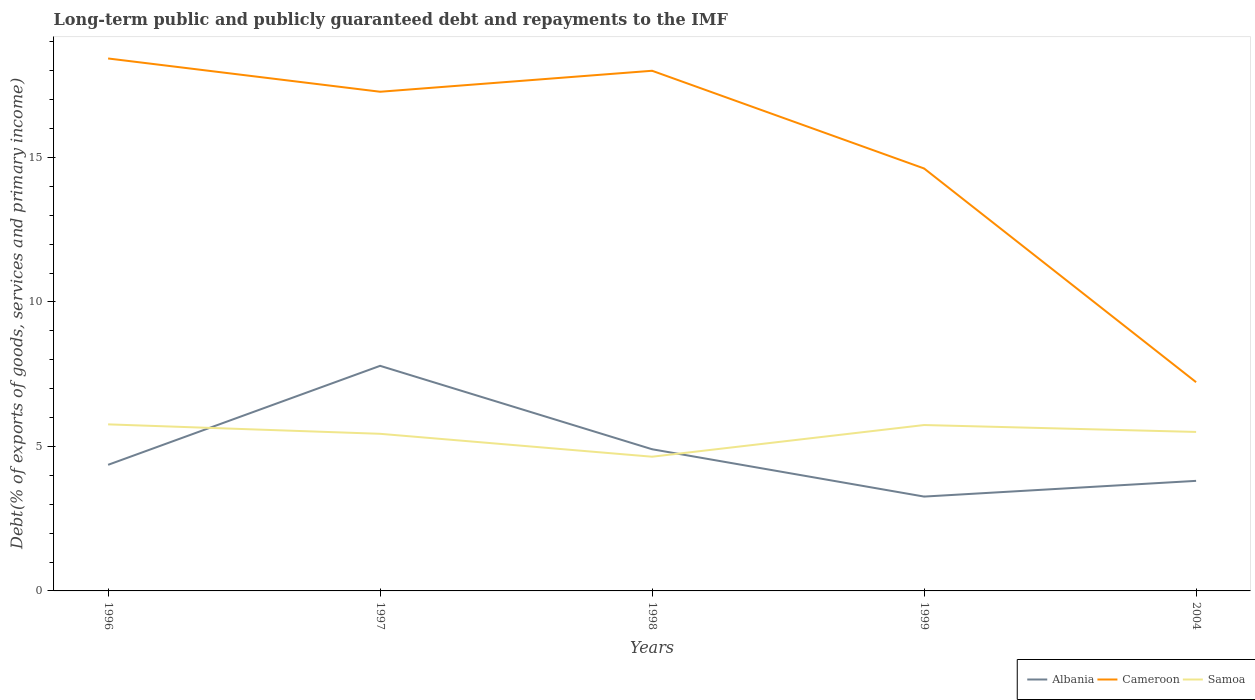How many different coloured lines are there?
Make the answer very short. 3. Does the line corresponding to Cameroon intersect with the line corresponding to Albania?
Your answer should be very brief. No. Across all years, what is the maximum debt and repayments in Cameroon?
Your answer should be very brief. 7.22. What is the total debt and repayments in Samoa in the graph?
Your answer should be compact. 0.26. What is the difference between the highest and the second highest debt and repayments in Cameroon?
Provide a succinct answer. 11.2. What is the difference between the highest and the lowest debt and repayments in Cameroon?
Give a very brief answer. 3. Is the debt and repayments in Albania strictly greater than the debt and repayments in Cameroon over the years?
Your answer should be compact. Yes. How many years are there in the graph?
Ensure brevity in your answer.  5. What is the difference between two consecutive major ticks on the Y-axis?
Give a very brief answer. 5. Are the values on the major ticks of Y-axis written in scientific E-notation?
Offer a terse response. No. Where does the legend appear in the graph?
Your answer should be compact. Bottom right. What is the title of the graph?
Provide a short and direct response. Long-term public and publicly guaranteed debt and repayments to the IMF. What is the label or title of the Y-axis?
Keep it short and to the point. Debt(% of exports of goods, services and primary income). What is the Debt(% of exports of goods, services and primary income) in Albania in 1996?
Keep it short and to the point. 4.36. What is the Debt(% of exports of goods, services and primary income) of Cameroon in 1996?
Offer a terse response. 18.43. What is the Debt(% of exports of goods, services and primary income) in Samoa in 1996?
Offer a very short reply. 5.76. What is the Debt(% of exports of goods, services and primary income) in Albania in 1997?
Make the answer very short. 7.79. What is the Debt(% of exports of goods, services and primary income) of Cameroon in 1997?
Offer a terse response. 17.27. What is the Debt(% of exports of goods, services and primary income) of Samoa in 1997?
Ensure brevity in your answer.  5.44. What is the Debt(% of exports of goods, services and primary income) of Albania in 1998?
Offer a terse response. 4.9. What is the Debt(% of exports of goods, services and primary income) in Cameroon in 1998?
Give a very brief answer. 18. What is the Debt(% of exports of goods, services and primary income) of Samoa in 1998?
Your answer should be very brief. 4.64. What is the Debt(% of exports of goods, services and primary income) of Albania in 1999?
Your answer should be very brief. 3.26. What is the Debt(% of exports of goods, services and primary income) of Cameroon in 1999?
Offer a very short reply. 14.62. What is the Debt(% of exports of goods, services and primary income) of Samoa in 1999?
Keep it short and to the point. 5.74. What is the Debt(% of exports of goods, services and primary income) in Albania in 2004?
Give a very brief answer. 3.81. What is the Debt(% of exports of goods, services and primary income) of Cameroon in 2004?
Your answer should be very brief. 7.22. What is the Debt(% of exports of goods, services and primary income) of Samoa in 2004?
Make the answer very short. 5.5. Across all years, what is the maximum Debt(% of exports of goods, services and primary income) of Albania?
Provide a succinct answer. 7.79. Across all years, what is the maximum Debt(% of exports of goods, services and primary income) in Cameroon?
Give a very brief answer. 18.43. Across all years, what is the maximum Debt(% of exports of goods, services and primary income) of Samoa?
Your answer should be very brief. 5.76. Across all years, what is the minimum Debt(% of exports of goods, services and primary income) of Albania?
Offer a very short reply. 3.26. Across all years, what is the minimum Debt(% of exports of goods, services and primary income) of Cameroon?
Ensure brevity in your answer.  7.22. Across all years, what is the minimum Debt(% of exports of goods, services and primary income) in Samoa?
Keep it short and to the point. 4.64. What is the total Debt(% of exports of goods, services and primary income) in Albania in the graph?
Your answer should be compact. 24.13. What is the total Debt(% of exports of goods, services and primary income) in Cameroon in the graph?
Offer a terse response. 75.54. What is the total Debt(% of exports of goods, services and primary income) of Samoa in the graph?
Offer a terse response. 27.09. What is the difference between the Debt(% of exports of goods, services and primary income) in Albania in 1996 and that in 1997?
Your answer should be very brief. -3.43. What is the difference between the Debt(% of exports of goods, services and primary income) of Cameroon in 1996 and that in 1997?
Ensure brevity in your answer.  1.15. What is the difference between the Debt(% of exports of goods, services and primary income) of Samoa in 1996 and that in 1997?
Provide a short and direct response. 0.33. What is the difference between the Debt(% of exports of goods, services and primary income) in Albania in 1996 and that in 1998?
Make the answer very short. -0.54. What is the difference between the Debt(% of exports of goods, services and primary income) in Cameroon in 1996 and that in 1998?
Ensure brevity in your answer.  0.43. What is the difference between the Debt(% of exports of goods, services and primary income) in Samoa in 1996 and that in 1998?
Your answer should be compact. 1.12. What is the difference between the Debt(% of exports of goods, services and primary income) in Albania in 1996 and that in 1999?
Provide a succinct answer. 1.1. What is the difference between the Debt(% of exports of goods, services and primary income) of Cameroon in 1996 and that in 1999?
Offer a terse response. 3.81. What is the difference between the Debt(% of exports of goods, services and primary income) in Samoa in 1996 and that in 1999?
Your answer should be very brief. 0.02. What is the difference between the Debt(% of exports of goods, services and primary income) in Albania in 1996 and that in 2004?
Offer a very short reply. 0.56. What is the difference between the Debt(% of exports of goods, services and primary income) of Cameroon in 1996 and that in 2004?
Your answer should be very brief. 11.2. What is the difference between the Debt(% of exports of goods, services and primary income) in Samoa in 1996 and that in 2004?
Make the answer very short. 0.26. What is the difference between the Debt(% of exports of goods, services and primary income) of Albania in 1997 and that in 1998?
Provide a short and direct response. 2.89. What is the difference between the Debt(% of exports of goods, services and primary income) in Cameroon in 1997 and that in 1998?
Your answer should be very brief. -0.73. What is the difference between the Debt(% of exports of goods, services and primary income) of Samoa in 1997 and that in 1998?
Offer a very short reply. 0.79. What is the difference between the Debt(% of exports of goods, services and primary income) in Albania in 1997 and that in 1999?
Offer a terse response. 4.52. What is the difference between the Debt(% of exports of goods, services and primary income) in Cameroon in 1997 and that in 1999?
Give a very brief answer. 2.65. What is the difference between the Debt(% of exports of goods, services and primary income) of Samoa in 1997 and that in 1999?
Provide a short and direct response. -0.3. What is the difference between the Debt(% of exports of goods, services and primary income) of Albania in 1997 and that in 2004?
Ensure brevity in your answer.  3.98. What is the difference between the Debt(% of exports of goods, services and primary income) in Cameroon in 1997 and that in 2004?
Keep it short and to the point. 10.05. What is the difference between the Debt(% of exports of goods, services and primary income) of Samoa in 1997 and that in 2004?
Make the answer very short. -0.06. What is the difference between the Debt(% of exports of goods, services and primary income) of Albania in 1998 and that in 1999?
Your answer should be compact. 1.64. What is the difference between the Debt(% of exports of goods, services and primary income) in Cameroon in 1998 and that in 1999?
Your answer should be compact. 3.38. What is the difference between the Debt(% of exports of goods, services and primary income) of Samoa in 1998 and that in 1999?
Keep it short and to the point. -1.1. What is the difference between the Debt(% of exports of goods, services and primary income) of Albania in 1998 and that in 2004?
Offer a very short reply. 1.09. What is the difference between the Debt(% of exports of goods, services and primary income) of Cameroon in 1998 and that in 2004?
Provide a short and direct response. 10.78. What is the difference between the Debt(% of exports of goods, services and primary income) in Samoa in 1998 and that in 2004?
Make the answer very short. -0.86. What is the difference between the Debt(% of exports of goods, services and primary income) in Albania in 1999 and that in 2004?
Keep it short and to the point. -0.54. What is the difference between the Debt(% of exports of goods, services and primary income) of Cameroon in 1999 and that in 2004?
Offer a very short reply. 7.4. What is the difference between the Debt(% of exports of goods, services and primary income) of Samoa in 1999 and that in 2004?
Offer a terse response. 0.24. What is the difference between the Debt(% of exports of goods, services and primary income) in Albania in 1996 and the Debt(% of exports of goods, services and primary income) in Cameroon in 1997?
Your response must be concise. -12.91. What is the difference between the Debt(% of exports of goods, services and primary income) of Albania in 1996 and the Debt(% of exports of goods, services and primary income) of Samoa in 1997?
Your response must be concise. -1.07. What is the difference between the Debt(% of exports of goods, services and primary income) in Cameroon in 1996 and the Debt(% of exports of goods, services and primary income) in Samoa in 1997?
Make the answer very short. 12.99. What is the difference between the Debt(% of exports of goods, services and primary income) in Albania in 1996 and the Debt(% of exports of goods, services and primary income) in Cameroon in 1998?
Provide a succinct answer. -13.64. What is the difference between the Debt(% of exports of goods, services and primary income) in Albania in 1996 and the Debt(% of exports of goods, services and primary income) in Samoa in 1998?
Give a very brief answer. -0.28. What is the difference between the Debt(% of exports of goods, services and primary income) in Cameroon in 1996 and the Debt(% of exports of goods, services and primary income) in Samoa in 1998?
Your answer should be very brief. 13.78. What is the difference between the Debt(% of exports of goods, services and primary income) in Albania in 1996 and the Debt(% of exports of goods, services and primary income) in Cameroon in 1999?
Give a very brief answer. -10.26. What is the difference between the Debt(% of exports of goods, services and primary income) of Albania in 1996 and the Debt(% of exports of goods, services and primary income) of Samoa in 1999?
Give a very brief answer. -1.38. What is the difference between the Debt(% of exports of goods, services and primary income) of Cameroon in 1996 and the Debt(% of exports of goods, services and primary income) of Samoa in 1999?
Your answer should be very brief. 12.68. What is the difference between the Debt(% of exports of goods, services and primary income) in Albania in 1996 and the Debt(% of exports of goods, services and primary income) in Cameroon in 2004?
Your response must be concise. -2.86. What is the difference between the Debt(% of exports of goods, services and primary income) of Albania in 1996 and the Debt(% of exports of goods, services and primary income) of Samoa in 2004?
Give a very brief answer. -1.14. What is the difference between the Debt(% of exports of goods, services and primary income) of Cameroon in 1996 and the Debt(% of exports of goods, services and primary income) of Samoa in 2004?
Offer a terse response. 12.92. What is the difference between the Debt(% of exports of goods, services and primary income) of Albania in 1997 and the Debt(% of exports of goods, services and primary income) of Cameroon in 1998?
Offer a terse response. -10.21. What is the difference between the Debt(% of exports of goods, services and primary income) in Albania in 1997 and the Debt(% of exports of goods, services and primary income) in Samoa in 1998?
Provide a succinct answer. 3.14. What is the difference between the Debt(% of exports of goods, services and primary income) of Cameroon in 1997 and the Debt(% of exports of goods, services and primary income) of Samoa in 1998?
Your response must be concise. 12.63. What is the difference between the Debt(% of exports of goods, services and primary income) of Albania in 1997 and the Debt(% of exports of goods, services and primary income) of Cameroon in 1999?
Offer a terse response. -6.83. What is the difference between the Debt(% of exports of goods, services and primary income) in Albania in 1997 and the Debt(% of exports of goods, services and primary income) in Samoa in 1999?
Give a very brief answer. 2.05. What is the difference between the Debt(% of exports of goods, services and primary income) in Cameroon in 1997 and the Debt(% of exports of goods, services and primary income) in Samoa in 1999?
Your answer should be compact. 11.53. What is the difference between the Debt(% of exports of goods, services and primary income) in Albania in 1997 and the Debt(% of exports of goods, services and primary income) in Cameroon in 2004?
Provide a succinct answer. 0.57. What is the difference between the Debt(% of exports of goods, services and primary income) in Albania in 1997 and the Debt(% of exports of goods, services and primary income) in Samoa in 2004?
Provide a succinct answer. 2.29. What is the difference between the Debt(% of exports of goods, services and primary income) in Cameroon in 1997 and the Debt(% of exports of goods, services and primary income) in Samoa in 2004?
Make the answer very short. 11.77. What is the difference between the Debt(% of exports of goods, services and primary income) of Albania in 1998 and the Debt(% of exports of goods, services and primary income) of Cameroon in 1999?
Provide a short and direct response. -9.72. What is the difference between the Debt(% of exports of goods, services and primary income) in Albania in 1998 and the Debt(% of exports of goods, services and primary income) in Samoa in 1999?
Keep it short and to the point. -0.84. What is the difference between the Debt(% of exports of goods, services and primary income) in Cameroon in 1998 and the Debt(% of exports of goods, services and primary income) in Samoa in 1999?
Your response must be concise. 12.26. What is the difference between the Debt(% of exports of goods, services and primary income) in Albania in 1998 and the Debt(% of exports of goods, services and primary income) in Cameroon in 2004?
Your answer should be very brief. -2.32. What is the difference between the Debt(% of exports of goods, services and primary income) of Albania in 1998 and the Debt(% of exports of goods, services and primary income) of Samoa in 2004?
Your answer should be compact. -0.6. What is the difference between the Debt(% of exports of goods, services and primary income) in Cameroon in 1998 and the Debt(% of exports of goods, services and primary income) in Samoa in 2004?
Your response must be concise. 12.5. What is the difference between the Debt(% of exports of goods, services and primary income) of Albania in 1999 and the Debt(% of exports of goods, services and primary income) of Cameroon in 2004?
Your answer should be compact. -3.96. What is the difference between the Debt(% of exports of goods, services and primary income) of Albania in 1999 and the Debt(% of exports of goods, services and primary income) of Samoa in 2004?
Provide a succinct answer. -2.24. What is the difference between the Debt(% of exports of goods, services and primary income) in Cameroon in 1999 and the Debt(% of exports of goods, services and primary income) in Samoa in 2004?
Offer a very short reply. 9.12. What is the average Debt(% of exports of goods, services and primary income) of Albania per year?
Your response must be concise. 4.83. What is the average Debt(% of exports of goods, services and primary income) of Cameroon per year?
Your answer should be very brief. 15.11. What is the average Debt(% of exports of goods, services and primary income) in Samoa per year?
Ensure brevity in your answer.  5.42. In the year 1996, what is the difference between the Debt(% of exports of goods, services and primary income) of Albania and Debt(% of exports of goods, services and primary income) of Cameroon?
Ensure brevity in your answer.  -14.06. In the year 1996, what is the difference between the Debt(% of exports of goods, services and primary income) of Albania and Debt(% of exports of goods, services and primary income) of Samoa?
Ensure brevity in your answer.  -1.4. In the year 1996, what is the difference between the Debt(% of exports of goods, services and primary income) in Cameroon and Debt(% of exports of goods, services and primary income) in Samoa?
Your answer should be very brief. 12.66. In the year 1997, what is the difference between the Debt(% of exports of goods, services and primary income) of Albania and Debt(% of exports of goods, services and primary income) of Cameroon?
Provide a short and direct response. -9.48. In the year 1997, what is the difference between the Debt(% of exports of goods, services and primary income) in Albania and Debt(% of exports of goods, services and primary income) in Samoa?
Make the answer very short. 2.35. In the year 1997, what is the difference between the Debt(% of exports of goods, services and primary income) of Cameroon and Debt(% of exports of goods, services and primary income) of Samoa?
Keep it short and to the point. 11.84. In the year 1998, what is the difference between the Debt(% of exports of goods, services and primary income) in Albania and Debt(% of exports of goods, services and primary income) in Cameroon?
Your answer should be compact. -13.1. In the year 1998, what is the difference between the Debt(% of exports of goods, services and primary income) in Albania and Debt(% of exports of goods, services and primary income) in Samoa?
Your answer should be compact. 0.26. In the year 1998, what is the difference between the Debt(% of exports of goods, services and primary income) of Cameroon and Debt(% of exports of goods, services and primary income) of Samoa?
Give a very brief answer. 13.36. In the year 1999, what is the difference between the Debt(% of exports of goods, services and primary income) of Albania and Debt(% of exports of goods, services and primary income) of Cameroon?
Provide a short and direct response. -11.35. In the year 1999, what is the difference between the Debt(% of exports of goods, services and primary income) in Albania and Debt(% of exports of goods, services and primary income) in Samoa?
Your answer should be very brief. -2.48. In the year 1999, what is the difference between the Debt(% of exports of goods, services and primary income) in Cameroon and Debt(% of exports of goods, services and primary income) in Samoa?
Offer a very short reply. 8.88. In the year 2004, what is the difference between the Debt(% of exports of goods, services and primary income) in Albania and Debt(% of exports of goods, services and primary income) in Cameroon?
Your answer should be very brief. -3.41. In the year 2004, what is the difference between the Debt(% of exports of goods, services and primary income) in Albania and Debt(% of exports of goods, services and primary income) in Samoa?
Give a very brief answer. -1.69. In the year 2004, what is the difference between the Debt(% of exports of goods, services and primary income) in Cameroon and Debt(% of exports of goods, services and primary income) in Samoa?
Your answer should be compact. 1.72. What is the ratio of the Debt(% of exports of goods, services and primary income) in Albania in 1996 to that in 1997?
Your answer should be very brief. 0.56. What is the ratio of the Debt(% of exports of goods, services and primary income) in Cameroon in 1996 to that in 1997?
Your response must be concise. 1.07. What is the ratio of the Debt(% of exports of goods, services and primary income) in Samoa in 1996 to that in 1997?
Keep it short and to the point. 1.06. What is the ratio of the Debt(% of exports of goods, services and primary income) in Albania in 1996 to that in 1998?
Provide a short and direct response. 0.89. What is the ratio of the Debt(% of exports of goods, services and primary income) of Cameroon in 1996 to that in 1998?
Provide a short and direct response. 1.02. What is the ratio of the Debt(% of exports of goods, services and primary income) of Samoa in 1996 to that in 1998?
Your answer should be very brief. 1.24. What is the ratio of the Debt(% of exports of goods, services and primary income) in Albania in 1996 to that in 1999?
Ensure brevity in your answer.  1.34. What is the ratio of the Debt(% of exports of goods, services and primary income) in Cameroon in 1996 to that in 1999?
Your answer should be very brief. 1.26. What is the ratio of the Debt(% of exports of goods, services and primary income) of Samoa in 1996 to that in 1999?
Your answer should be compact. 1. What is the ratio of the Debt(% of exports of goods, services and primary income) in Albania in 1996 to that in 2004?
Provide a succinct answer. 1.15. What is the ratio of the Debt(% of exports of goods, services and primary income) in Cameroon in 1996 to that in 2004?
Your answer should be compact. 2.55. What is the ratio of the Debt(% of exports of goods, services and primary income) of Samoa in 1996 to that in 2004?
Provide a succinct answer. 1.05. What is the ratio of the Debt(% of exports of goods, services and primary income) in Albania in 1997 to that in 1998?
Ensure brevity in your answer.  1.59. What is the ratio of the Debt(% of exports of goods, services and primary income) of Cameroon in 1997 to that in 1998?
Offer a terse response. 0.96. What is the ratio of the Debt(% of exports of goods, services and primary income) of Samoa in 1997 to that in 1998?
Provide a succinct answer. 1.17. What is the ratio of the Debt(% of exports of goods, services and primary income) in Albania in 1997 to that in 1999?
Make the answer very short. 2.39. What is the ratio of the Debt(% of exports of goods, services and primary income) of Cameroon in 1997 to that in 1999?
Keep it short and to the point. 1.18. What is the ratio of the Debt(% of exports of goods, services and primary income) of Samoa in 1997 to that in 1999?
Your answer should be compact. 0.95. What is the ratio of the Debt(% of exports of goods, services and primary income) of Albania in 1997 to that in 2004?
Offer a terse response. 2.04. What is the ratio of the Debt(% of exports of goods, services and primary income) in Cameroon in 1997 to that in 2004?
Your answer should be very brief. 2.39. What is the ratio of the Debt(% of exports of goods, services and primary income) in Samoa in 1997 to that in 2004?
Provide a short and direct response. 0.99. What is the ratio of the Debt(% of exports of goods, services and primary income) of Albania in 1998 to that in 1999?
Give a very brief answer. 1.5. What is the ratio of the Debt(% of exports of goods, services and primary income) of Cameroon in 1998 to that in 1999?
Your answer should be very brief. 1.23. What is the ratio of the Debt(% of exports of goods, services and primary income) in Samoa in 1998 to that in 1999?
Ensure brevity in your answer.  0.81. What is the ratio of the Debt(% of exports of goods, services and primary income) of Albania in 1998 to that in 2004?
Provide a short and direct response. 1.29. What is the ratio of the Debt(% of exports of goods, services and primary income) of Cameroon in 1998 to that in 2004?
Your response must be concise. 2.49. What is the ratio of the Debt(% of exports of goods, services and primary income) of Samoa in 1998 to that in 2004?
Provide a succinct answer. 0.84. What is the ratio of the Debt(% of exports of goods, services and primary income) in Albania in 1999 to that in 2004?
Make the answer very short. 0.86. What is the ratio of the Debt(% of exports of goods, services and primary income) in Cameroon in 1999 to that in 2004?
Ensure brevity in your answer.  2.02. What is the ratio of the Debt(% of exports of goods, services and primary income) in Samoa in 1999 to that in 2004?
Ensure brevity in your answer.  1.04. What is the difference between the highest and the second highest Debt(% of exports of goods, services and primary income) of Albania?
Your response must be concise. 2.89. What is the difference between the highest and the second highest Debt(% of exports of goods, services and primary income) in Cameroon?
Provide a succinct answer. 0.43. What is the difference between the highest and the second highest Debt(% of exports of goods, services and primary income) of Samoa?
Your response must be concise. 0.02. What is the difference between the highest and the lowest Debt(% of exports of goods, services and primary income) of Albania?
Your answer should be compact. 4.52. What is the difference between the highest and the lowest Debt(% of exports of goods, services and primary income) in Cameroon?
Keep it short and to the point. 11.2. What is the difference between the highest and the lowest Debt(% of exports of goods, services and primary income) in Samoa?
Your answer should be very brief. 1.12. 